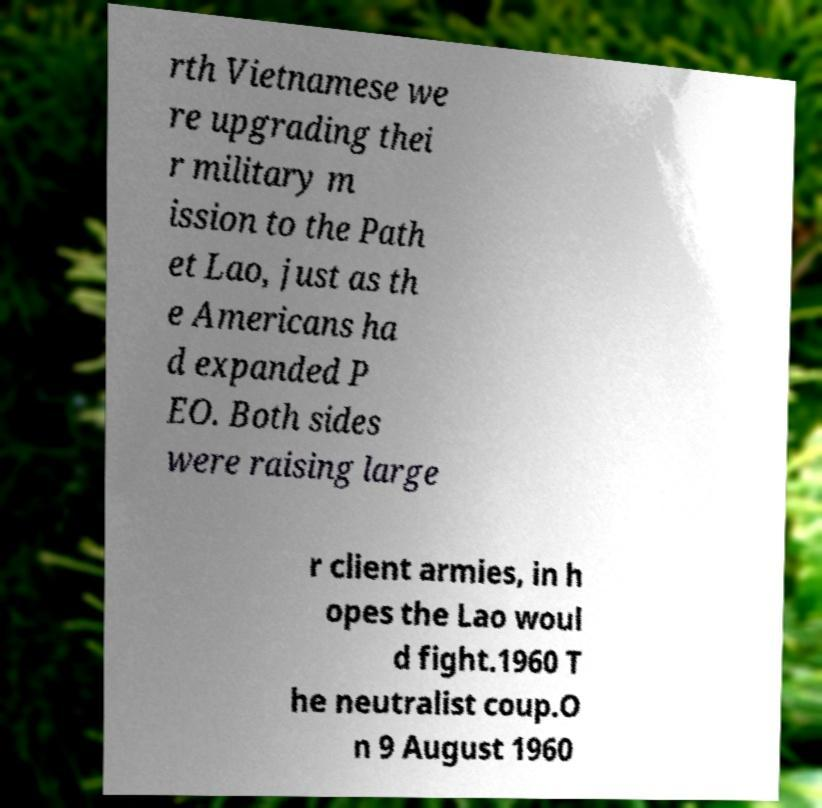I need the written content from this picture converted into text. Can you do that? rth Vietnamese we re upgrading thei r military m ission to the Path et Lao, just as th e Americans ha d expanded P EO. Both sides were raising large r client armies, in h opes the Lao woul d fight.1960 T he neutralist coup.O n 9 August 1960 